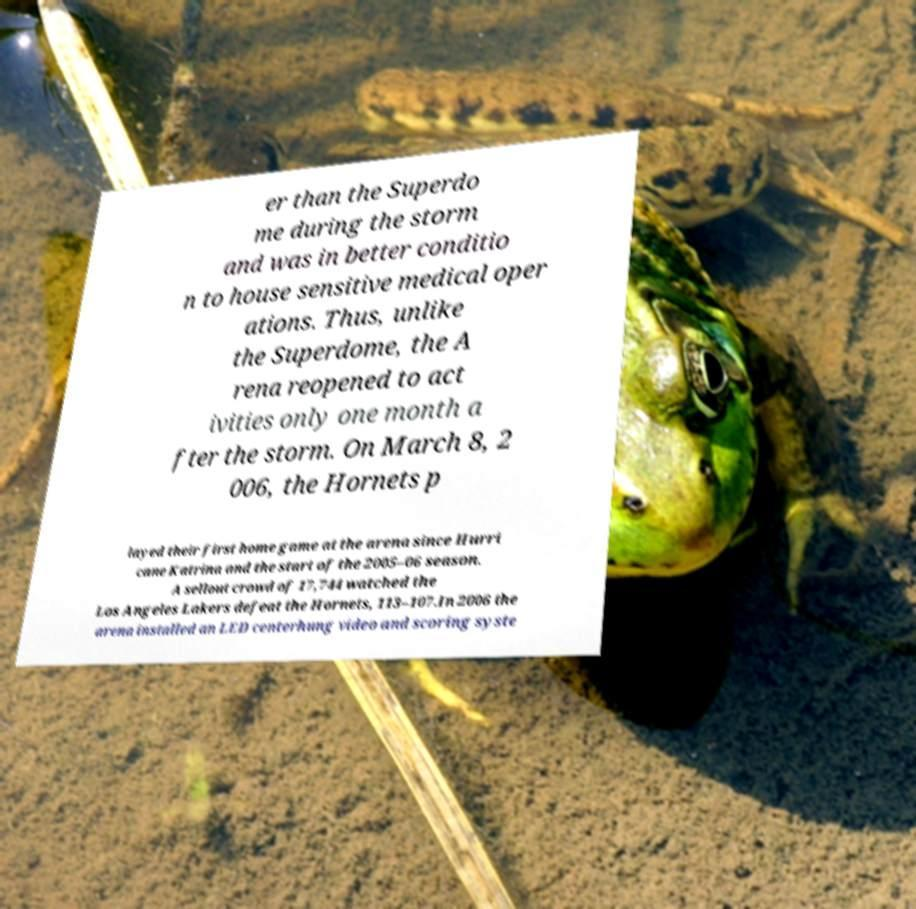There's text embedded in this image that I need extracted. Can you transcribe it verbatim? er than the Superdo me during the storm and was in better conditio n to house sensitive medical oper ations. Thus, unlike the Superdome, the A rena reopened to act ivities only one month a fter the storm. On March 8, 2 006, the Hornets p layed their first home game at the arena since Hurri cane Katrina and the start of the 2005–06 season. A sellout crowd of 17,744 watched the Los Angeles Lakers defeat the Hornets, 113–107.In 2006 the arena installed an LED centerhung video and scoring syste 